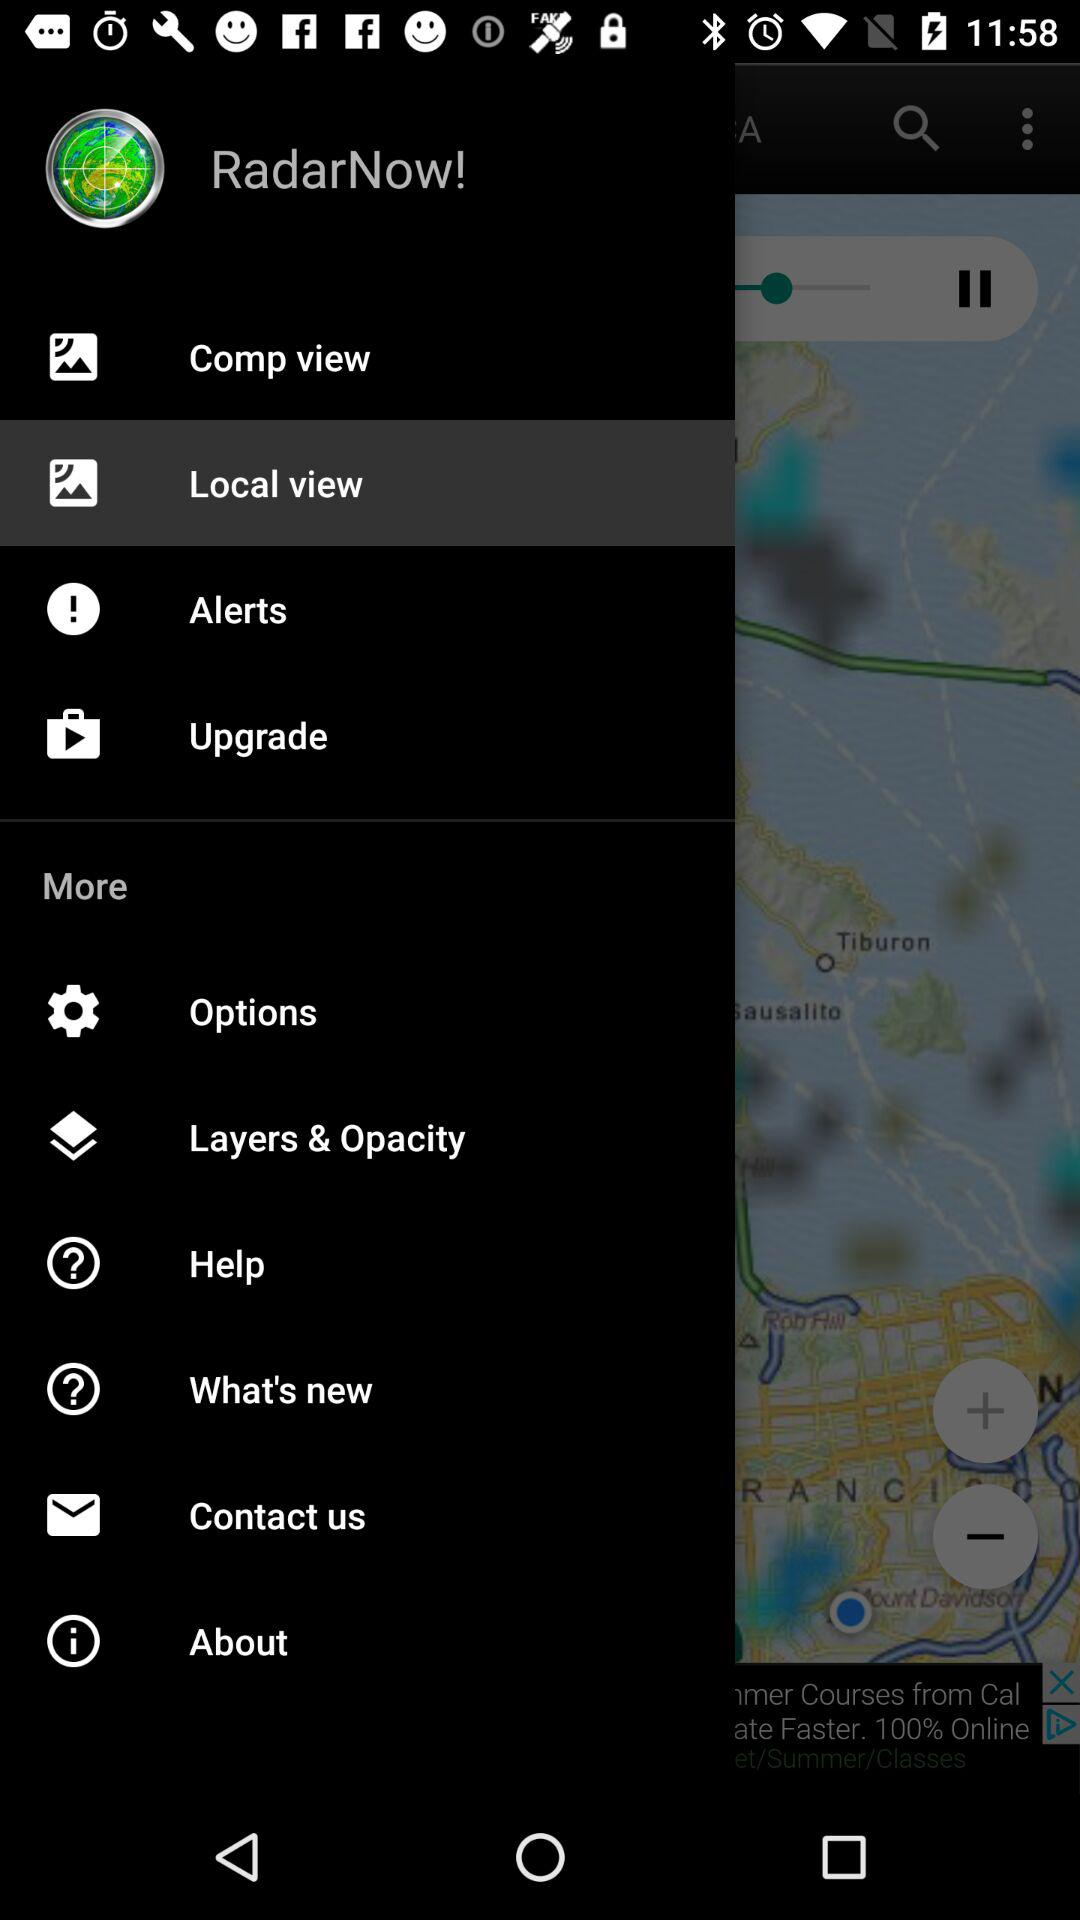Which item has been selected? The item that has been selected is "Local view". 